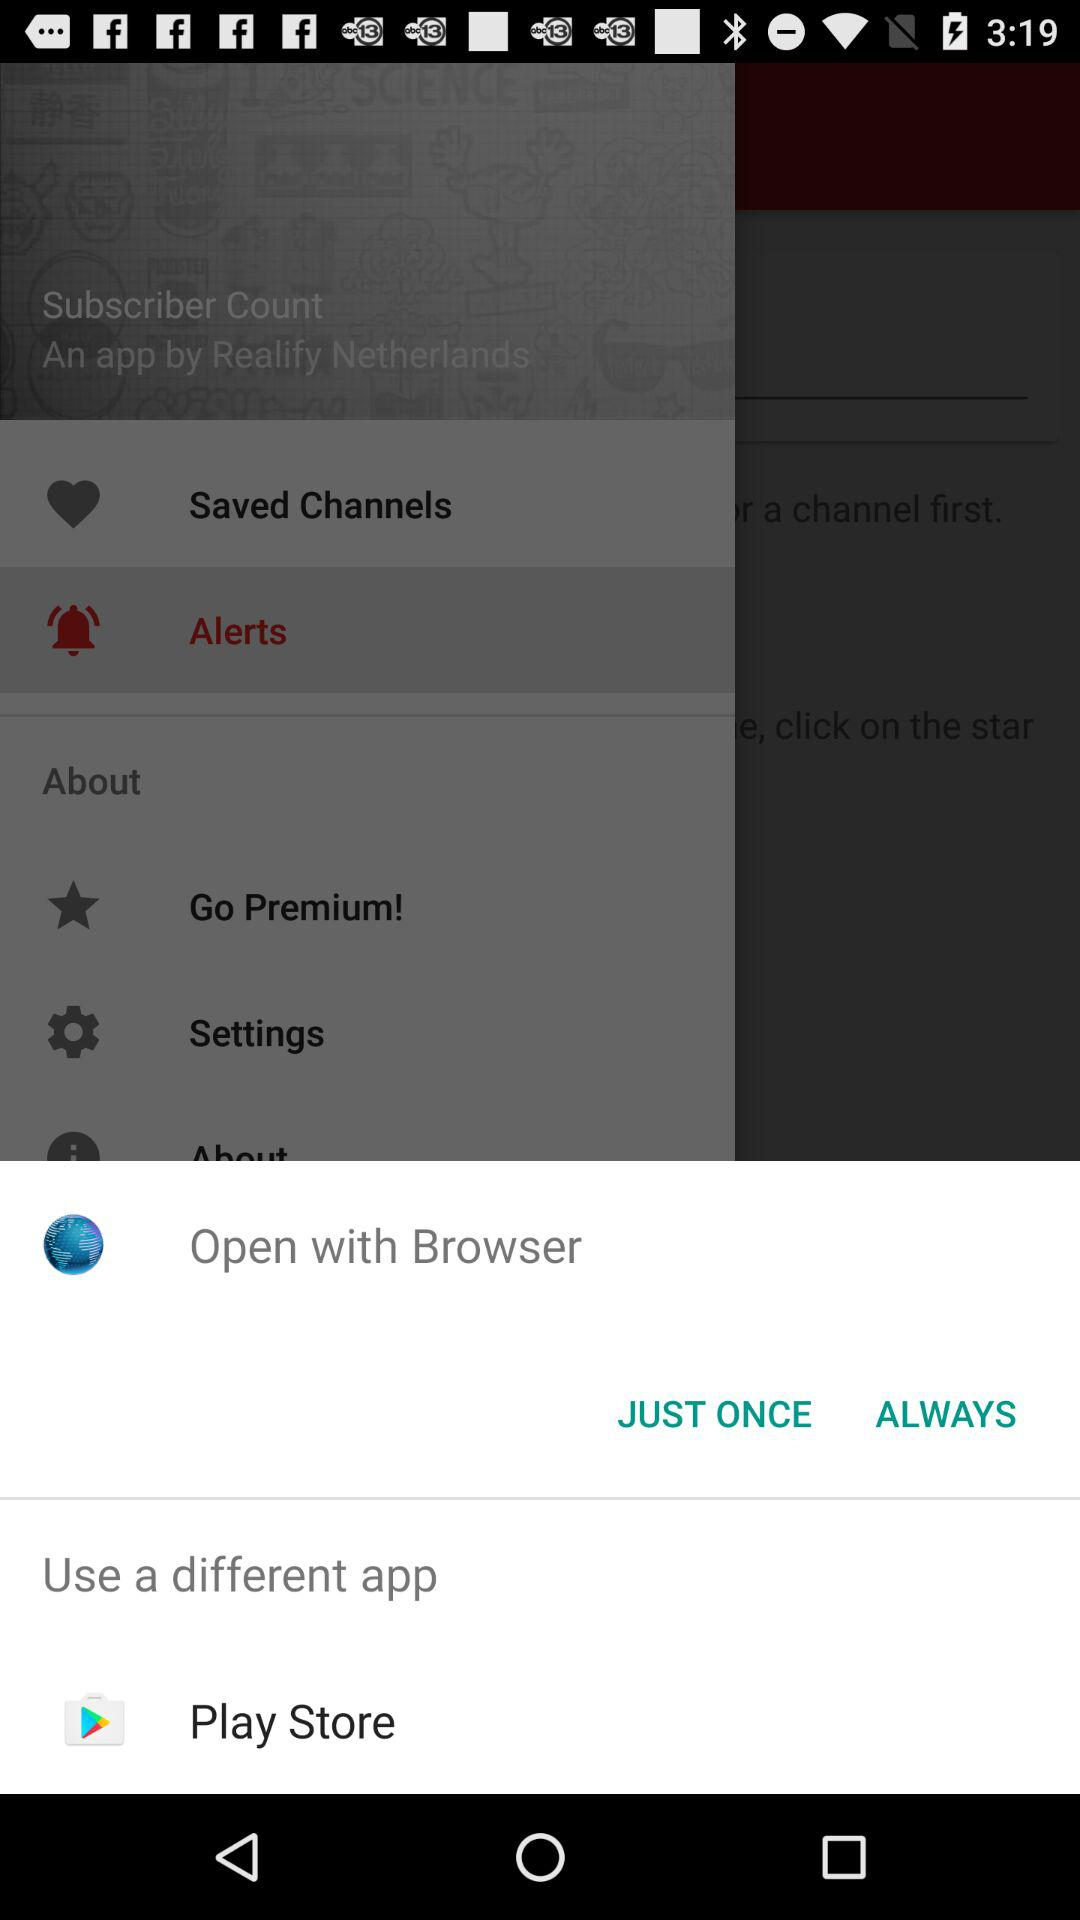What is the name of the different application? The name of the different application is "Play Store". 